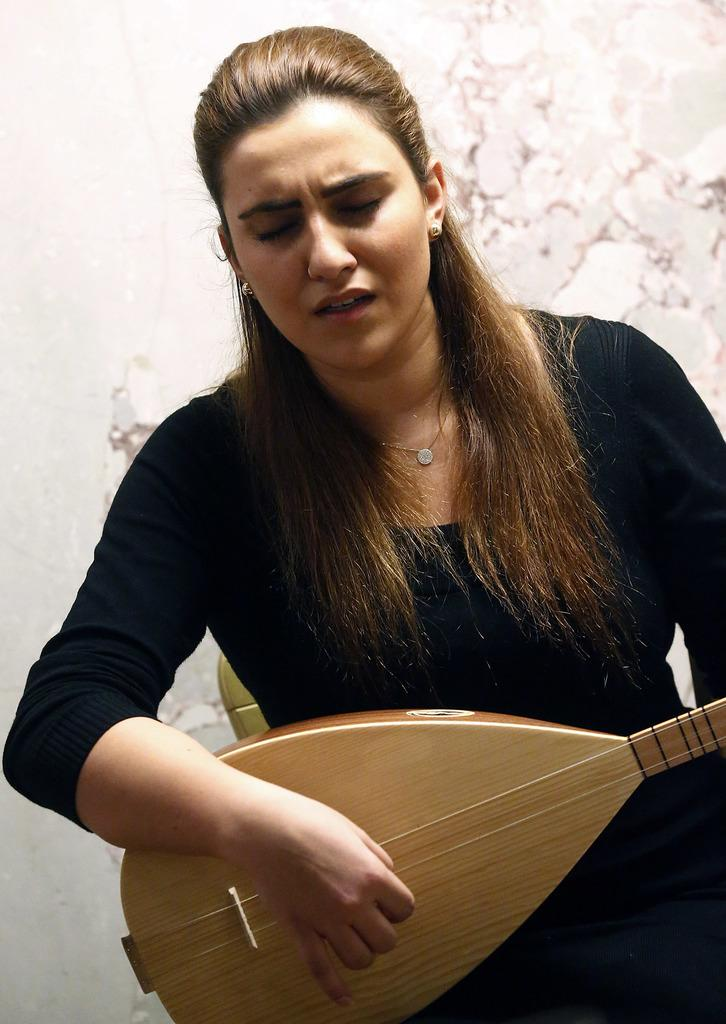Who is the main subject in the image? There is a woman in the image. What is the woman doing in the image? The woman is playing a musical instrument. What can be seen in the background of the image? There is a wall in the background of the image. Are there any boats visible in the image? No, there are no boats present in the image. Is the woman experiencing any trouble while playing the musical instrument? The image does not provide any information about the woman's experience or emotions while playing the musical instrument. 